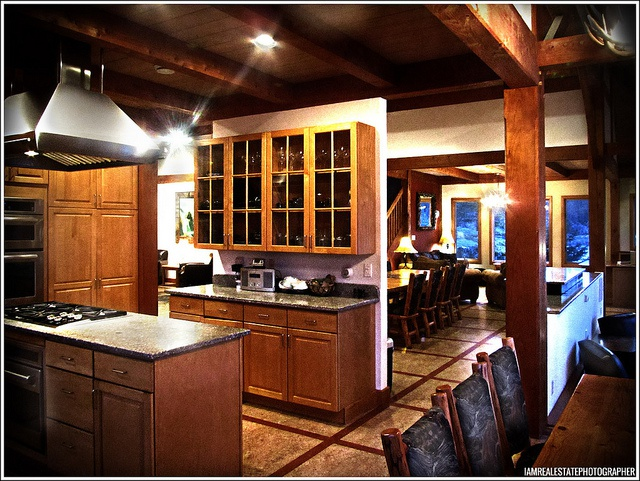Describe the objects in this image and their specific colors. I can see dining table in black, maroon, lightgray, and gray tones, oven in black, ivory, and gray tones, chair in black, gray, and maroon tones, chair in black, maroon, and gray tones, and chair in black, gray, and maroon tones in this image. 